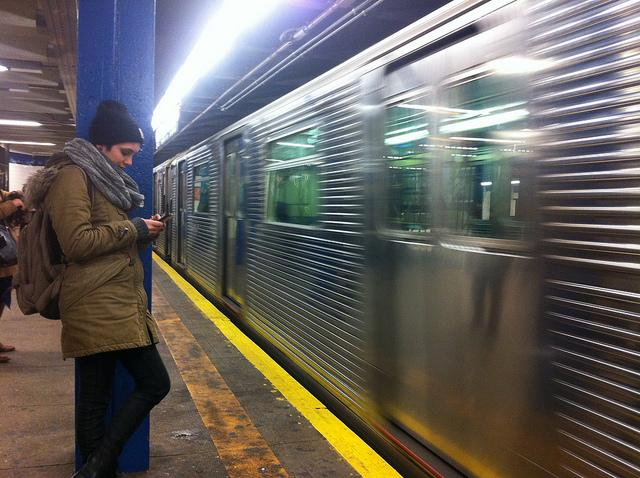What type of communication is she using?

Choices:
A) verbal
B) written
C) gestures
D) electronic electronic 